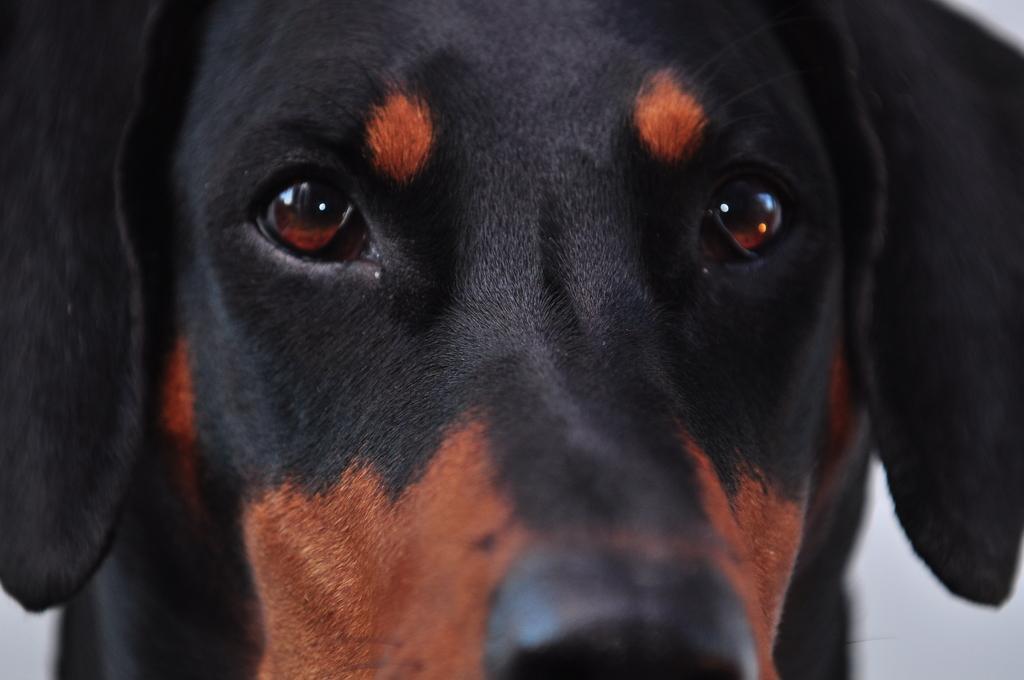How would you summarize this image in a sentence or two? In the given picture, I can see a dog with opened eyes. 